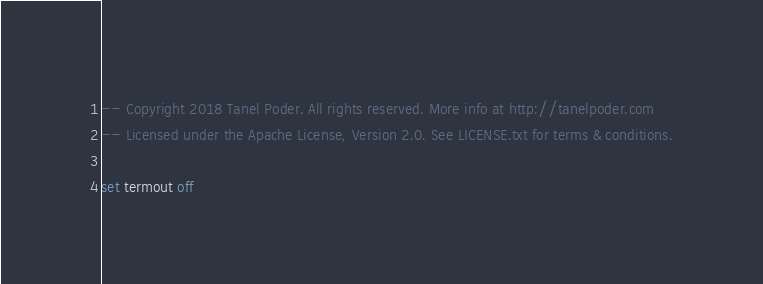<code> <loc_0><loc_0><loc_500><loc_500><_SQL_>-- Copyright 2018 Tanel Poder. All rights reserved. More info at http://tanelpoder.com
-- Licensed under the Apache License, Version 2.0. See LICENSE.txt for terms & conditions.

set termout off
</code> 